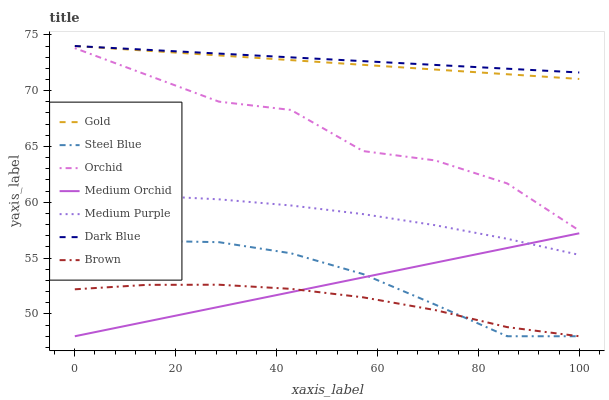Does Brown have the minimum area under the curve?
Answer yes or no. Yes. Does Dark Blue have the maximum area under the curve?
Answer yes or no. Yes. Does Gold have the minimum area under the curve?
Answer yes or no. No. Does Gold have the maximum area under the curve?
Answer yes or no. No. Is Medium Orchid the smoothest?
Answer yes or no. Yes. Is Orchid the roughest?
Answer yes or no. Yes. Is Gold the smoothest?
Answer yes or no. No. Is Gold the roughest?
Answer yes or no. No. Does Brown have the lowest value?
Answer yes or no. Yes. Does Gold have the lowest value?
Answer yes or no. No. Does Dark Blue have the highest value?
Answer yes or no. Yes. Does Medium Orchid have the highest value?
Answer yes or no. No. Is Medium Purple less than Dark Blue?
Answer yes or no. Yes. Is Gold greater than Brown?
Answer yes or no. Yes. Does Steel Blue intersect Medium Orchid?
Answer yes or no. Yes. Is Steel Blue less than Medium Orchid?
Answer yes or no. No. Is Steel Blue greater than Medium Orchid?
Answer yes or no. No. Does Medium Purple intersect Dark Blue?
Answer yes or no. No. 